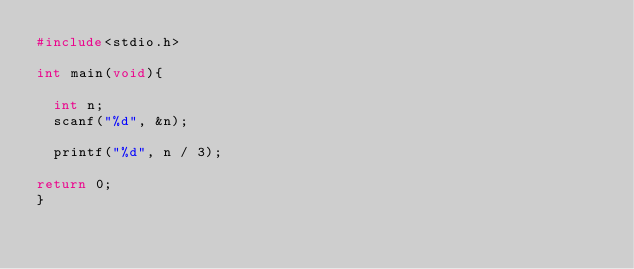Convert code to text. <code><loc_0><loc_0><loc_500><loc_500><_C_>#include<stdio.h>

int main(void){

  int n;
  scanf("%d", &n);

  printf("%d", n / 3);
  
return 0;
}</code> 